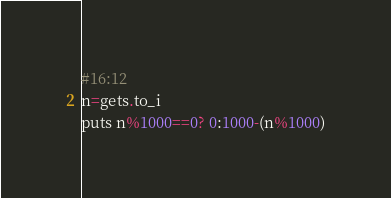Convert code to text. <code><loc_0><loc_0><loc_500><loc_500><_Ruby_>#16:12
n=gets.to_i
puts n%1000==0? 0:1000-(n%1000)
</code> 